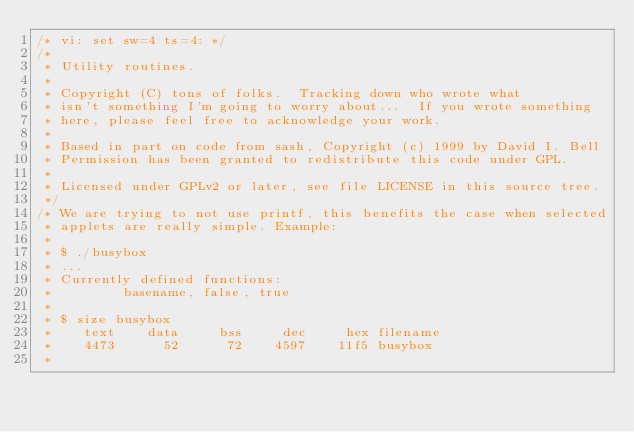<code> <loc_0><loc_0><loc_500><loc_500><_C_>/* vi: set sw=4 ts=4: */
/*
 * Utility routines.
 *
 * Copyright (C) tons of folks.  Tracking down who wrote what
 * isn't something I'm going to worry about...  If you wrote something
 * here, please feel free to acknowledge your work.
 *
 * Based in part on code from sash, Copyright (c) 1999 by David I. Bell
 * Permission has been granted to redistribute this code under GPL.
 *
 * Licensed under GPLv2 or later, see file LICENSE in this source tree.
 */
/* We are trying to not use printf, this benefits the case when selected
 * applets are really simple. Example:
 *
 * $ ./busybox
 * ...
 * Currently defined functions:
 *         basename, false, true
 *
 * $ size busybox
 *    text    data     bss     dec     hex filename
 *    4473      52      72    4597    11f5 busybox
 *</code> 